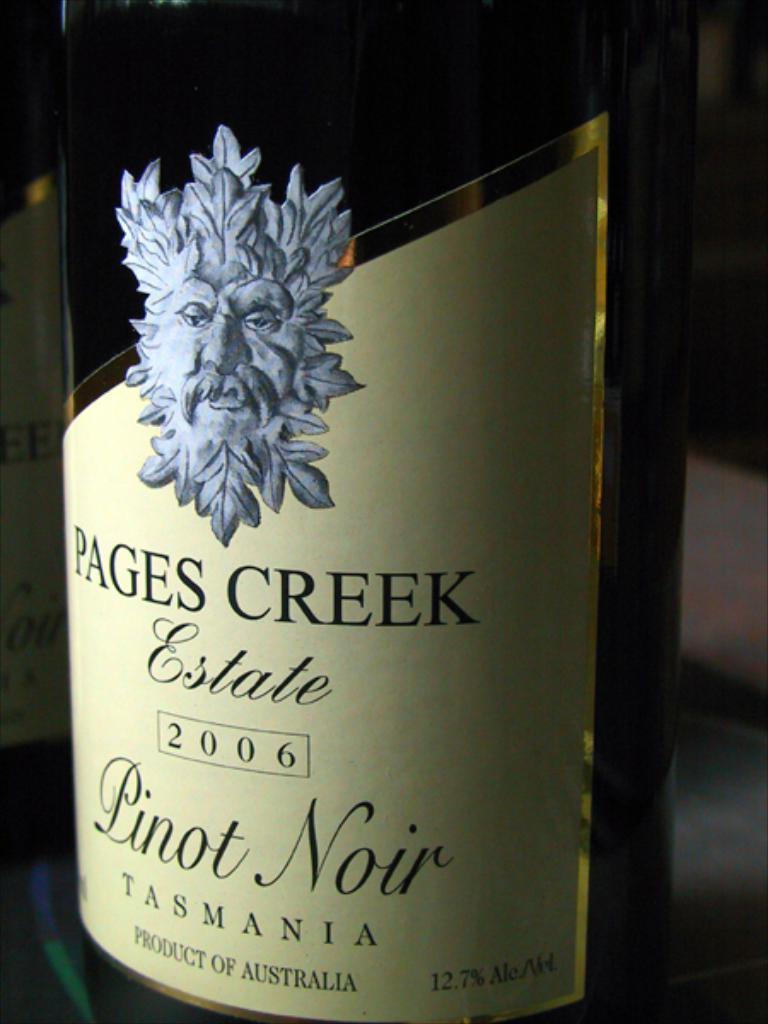In one or two sentences, can you explain what this image depicts? In the center of the image we can see a wine bottle placed on the table. 